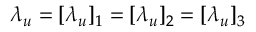<formula> <loc_0><loc_0><loc_500><loc_500>\lambda _ { u } = [ \lambda _ { u } ] _ { 1 } = [ \lambda _ { u } ] _ { 2 } = [ \lambda _ { u } ] _ { 3 }</formula> 